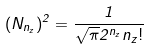<formula> <loc_0><loc_0><loc_500><loc_500>( N _ { n _ { z } } ) ^ { 2 } = \frac { 1 } { \sqrt { \pi } 2 ^ { n _ { z } } n _ { z } ! }</formula> 